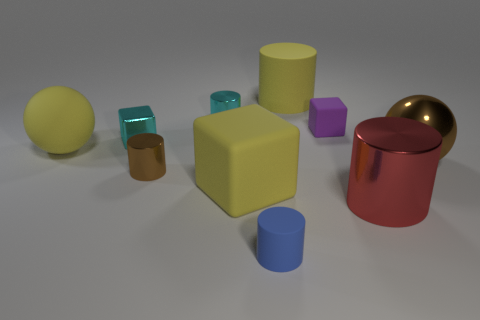There is a thing that is the same color as the metallic block; what shape is it?
Your answer should be compact. Cylinder. What is the color of the small rubber object that is behind the tiny brown cylinder?
Keep it short and to the point. Purple. How many things are brown metal things right of the large red cylinder or large green metal balls?
Make the answer very short. 1. The metallic cube that is the same size as the blue cylinder is what color?
Your answer should be very brief. Cyan. Is the number of large things that are in front of the red metallic cylinder greater than the number of cyan cylinders?
Make the answer very short. No. What is the material of the cube that is both in front of the purple rubber thing and behind the big yellow sphere?
Offer a terse response. Metal. Is the color of the ball that is on the left side of the large matte cube the same as the small object that is in front of the brown cylinder?
Your response must be concise. No. What number of other things are the same size as the yellow sphere?
Your response must be concise. 4. Are there any metal things right of the ball that is to the right of the big yellow thing to the left of the small brown cylinder?
Your response must be concise. No. Is the tiny thing that is in front of the red thing made of the same material as the tiny purple cube?
Provide a succinct answer. Yes. 